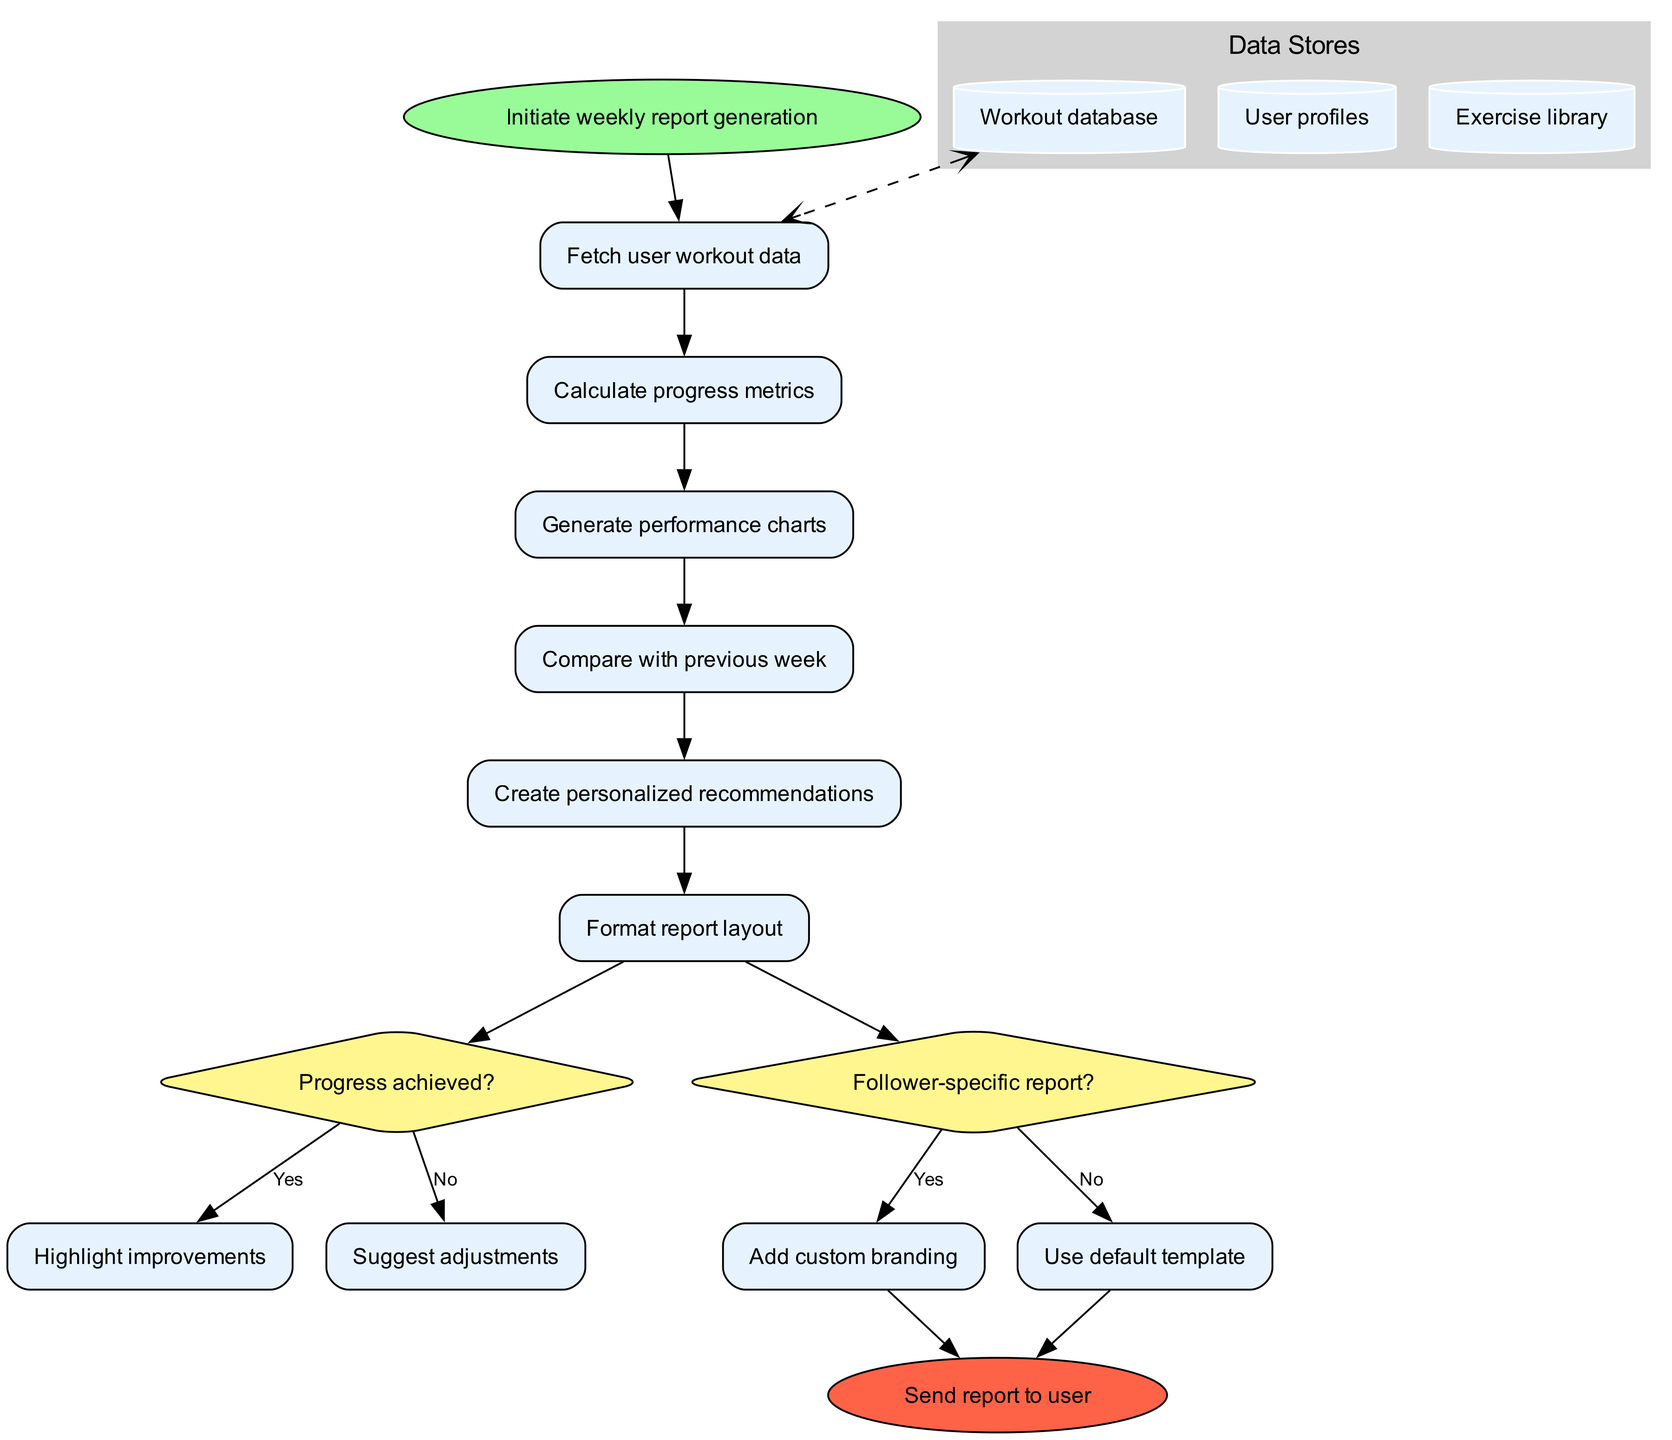What is the starting point of the diagram? The starting point, also known as the start node, is labeled "Initiate weekly report generation." This is the first action that occurs in the process flow.
Answer: Initiate weekly report generation How many processes are there in total? The diagram contains a total of six process nodes, which include actions like fetching user workout data and generating performance charts.
Answer: 6 What follows after calculating progress metrics? After calculating progress metrics, the next process is "Generate performance charts." This indicates the sequential order of actions in the flow.
Answer: Generate performance charts What is the condition for the first decision node? The condition for the first decision node is "Progress achieved?" This question determines the next steps based on whether progress has been made or not.
Answer: Progress achieved? If the answer to the first decision node is "no," what action is taken? If the answer is "no," the action taken is "Suggest adjustments," which is the path defined by the decision outcome. This suggests that improvements are necessary.
Answer: Suggest adjustments Which data store is connected to the starting process? The data store connected to the starting process "Fetch user workout data" is the "Workout database," indicating the source of the needed information for this process.
Answer: Workout database What happens if a follower-specific report is needed? If a follower-specific report is needed, the process will "Add custom branding," which personalizes the report based on the follower's identity. This occurs if the decision node evaluates to "yes."
Answer: Add custom branding How many data stores are included in the diagram? There are three data stores mentioned in the diagram: "Workout database," "User profiles," and "Exercise library," which hold different types of relevant information.
Answer: 3 What is the final node in the flowchart? The final node in the flowchart is labeled "Send report to user," which signifies the completion of the report generation process and its delivery.
Answer: Send report to user 